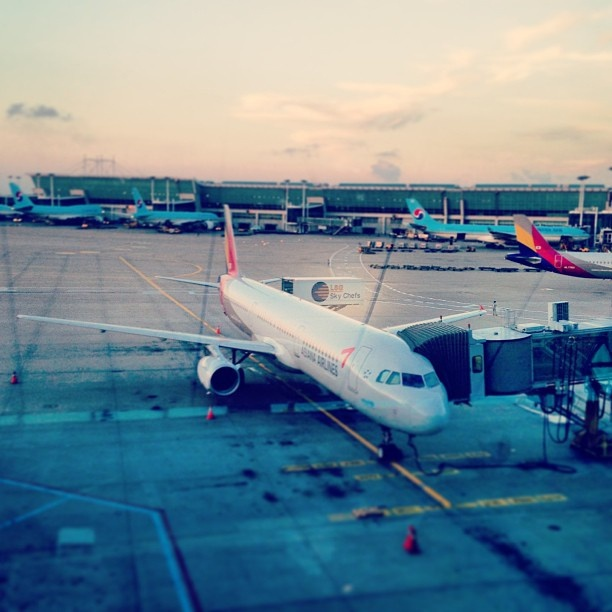Describe the objects in this image and their specific colors. I can see airplane in beige, darkgray, lightgray, gray, and navy tones, airplane in beige, navy, darkgray, purple, and orange tones, airplane in beige, teal, navy, and darkgray tones, airplane in beige, teal, navy, and blue tones, and airplane in beige, teal, navy, and blue tones in this image. 